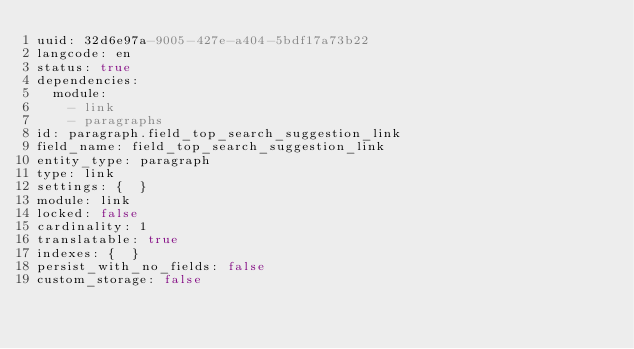<code> <loc_0><loc_0><loc_500><loc_500><_YAML_>uuid: 32d6e97a-9005-427e-a404-5bdf17a73b22
langcode: en
status: true
dependencies:
  module:
    - link
    - paragraphs
id: paragraph.field_top_search_suggestion_link
field_name: field_top_search_suggestion_link
entity_type: paragraph
type: link
settings: {  }
module: link
locked: false
cardinality: 1
translatable: true
indexes: {  }
persist_with_no_fields: false
custom_storage: false
</code> 